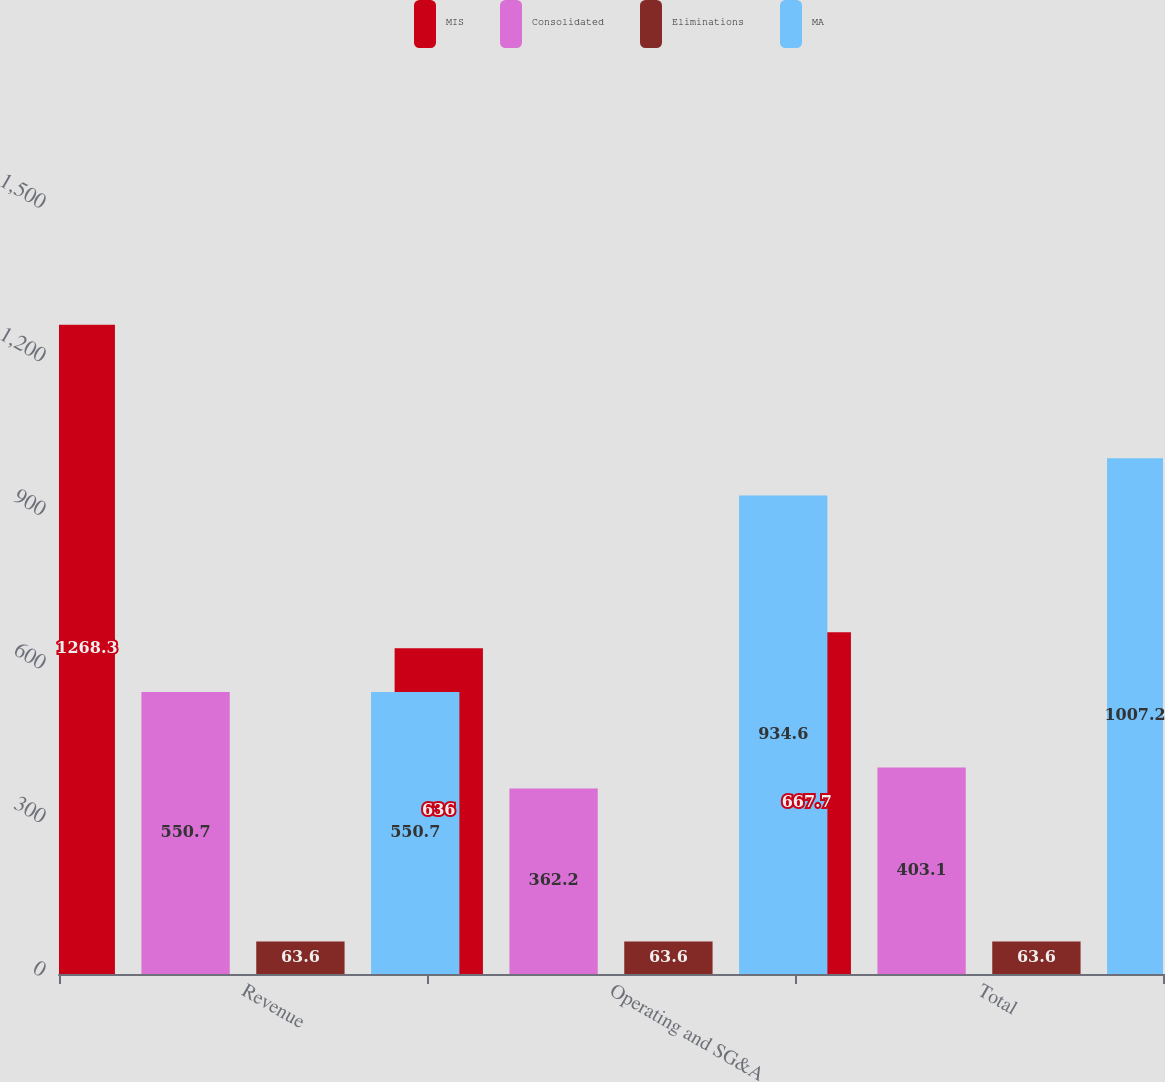<chart> <loc_0><loc_0><loc_500><loc_500><stacked_bar_chart><ecel><fcel>Revenue<fcel>Operating and SG&A<fcel>Total<nl><fcel>MIS<fcel>1268.3<fcel>636<fcel>667.7<nl><fcel>Consolidated<fcel>550.7<fcel>362.2<fcel>403.1<nl><fcel>Eliminations<fcel>63.6<fcel>63.6<fcel>63.6<nl><fcel>MA<fcel>550.7<fcel>934.6<fcel>1007.2<nl></chart> 